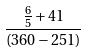<formula> <loc_0><loc_0><loc_500><loc_500>\frac { \frac { 6 } { 5 } + 4 1 } { ( 3 6 0 - 2 5 1 ) }</formula> 